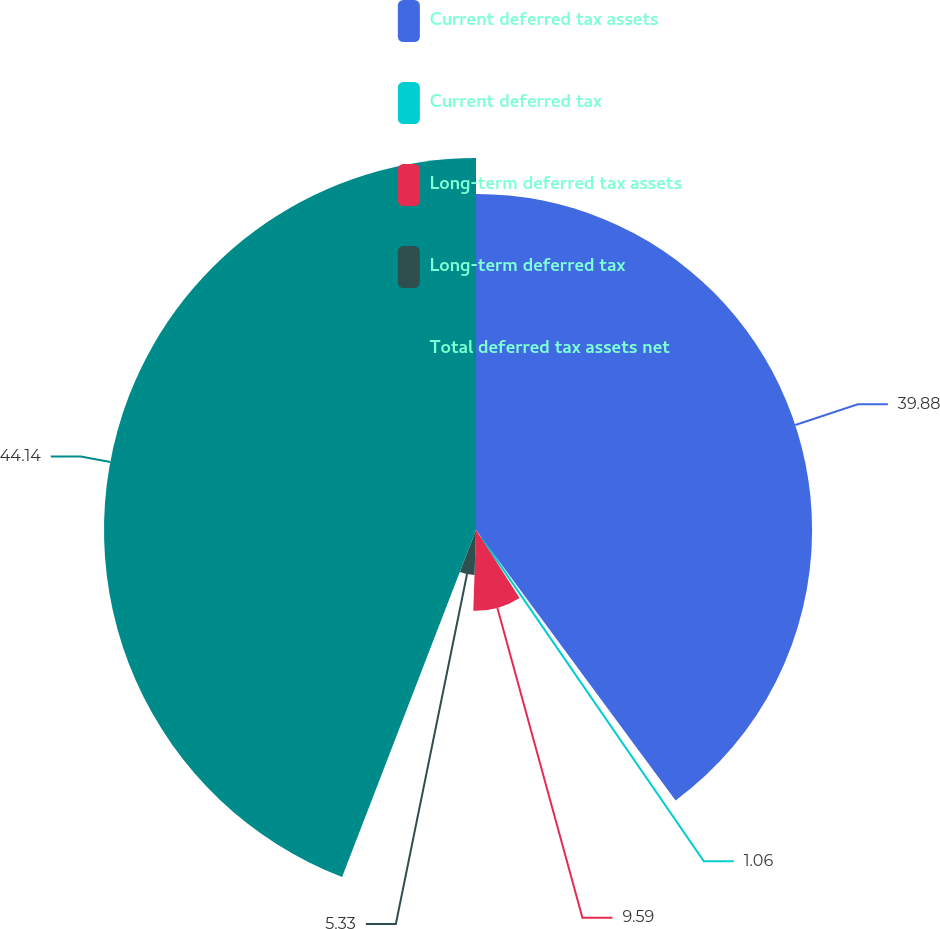Convert chart. <chart><loc_0><loc_0><loc_500><loc_500><pie_chart><fcel>Current deferred tax assets<fcel>Current deferred tax<fcel>Long-term deferred tax assets<fcel>Long-term deferred tax<fcel>Total deferred tax assets net<nl><fcel>39.88%<fcel>1.06%<fcel>9.59%<fcel>5.33%<fcel>44.14%<nl></chart> 